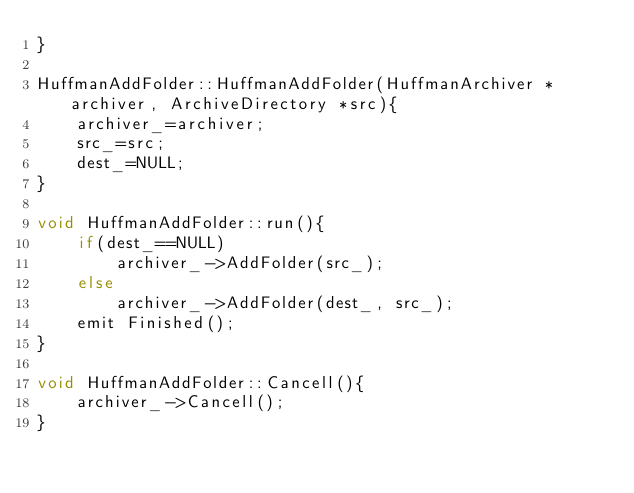Convert code to text. <code><loc_0><loc_0><loc_500><loc_500><_C++_>}

HuffmanAddFolder::HuffmanAddFolder(HuffmanArchiver *archiver, ArchiveDirectory *src){
    archiver_=archiver;
    src_=src;
    dest_=NULL;
}

void HuffmanAddFolder::run(){
    if(dest_==NULL)
        archiver_->AddFolder(src_);
    else
        archiver_->AddFolder(dest_, src_);
    emit Finished();
}

void HuffmanAddFolder::Cancell(){
    archiver_->Cancell();
}
</code> 